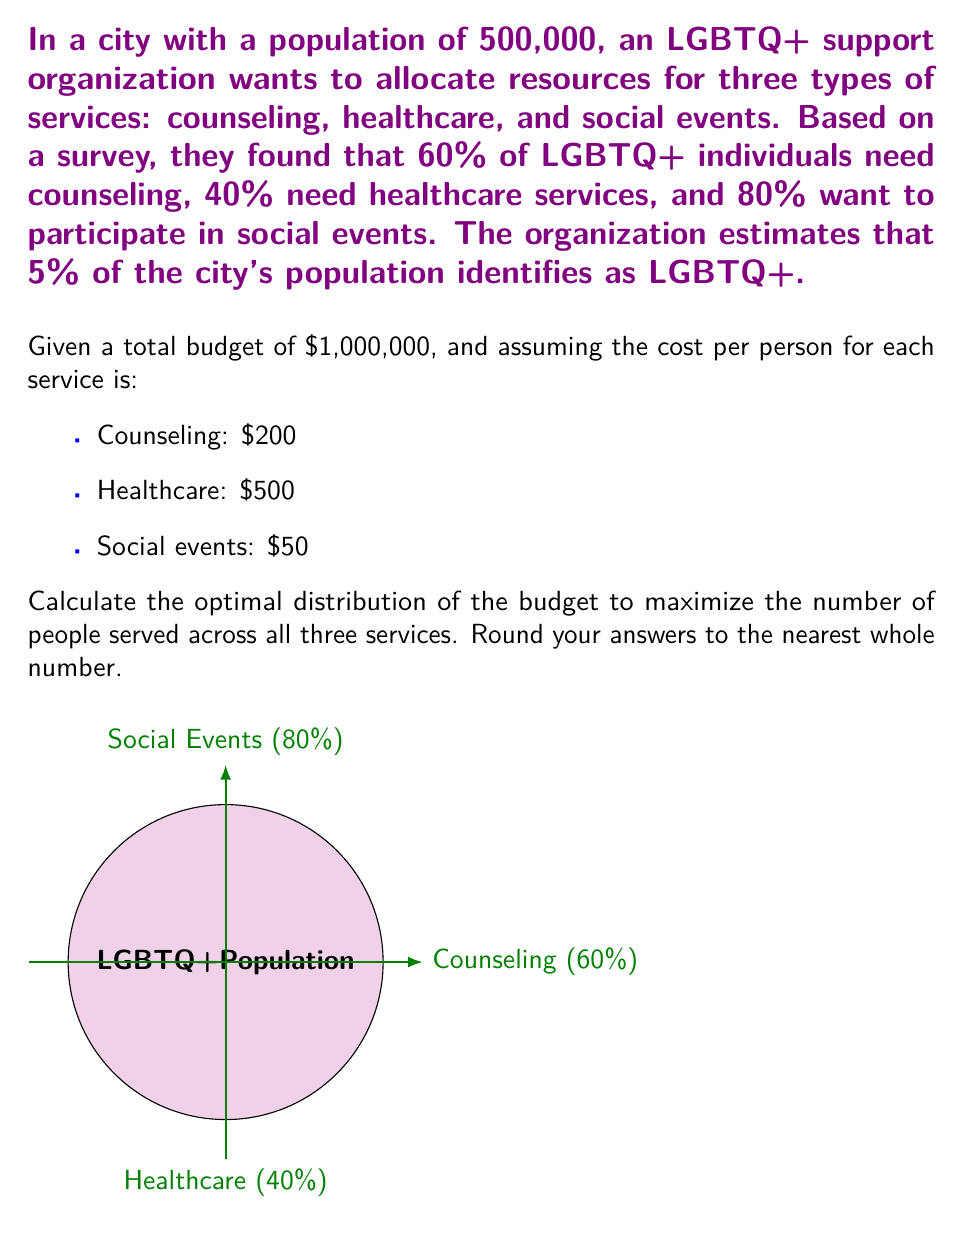Provide a solution to this math problem. Let's approach this step-by-step:

1) First, calculate the LGBTQ+ population in the city:
   $500,000 \times 5\% = 25,000$ LGBTQ+ individuals

2) Calculate the number of people needing each service:
   Counseling: $25,000 \times 60\% = 15,000$
   Healthcare: $25,000 \times 40\% = 10,000$
   Social events: $25,000 \times 80\% = 20,000$

3) Calculate the total cost if all needs were met:
   Counseling: $15,000 \times \$200 = \$3,000,000$
   Healthcare: $10,000 \times \$500 = \$5,000,000$
   Social events: $20,000 \times \$50 = \$1,000,000$
   Total: $\$9,000,000$

4) Since the budget is only $1,000,000, we need to distribute it optimally. To maximize the number of people served, we should prioritize the least expensive service first.

5) Allocate budget to social events:
   $20,000 \times \$50 = \$1,000,000$
   This exceeds the budget, so we can serve: $\frac{\$1,000,000}{\$50} = 20,000$ people

6) Remaining budget: $\$1,000,000 - \$1,000,000 = \$0$

7) There's no budget left for counseling or healthcare services.

8) Calculate the percentage of the budget for each service:
   Social events: $\frac{\$1,000,000}{\$1,000,000} \times 100\% = 100\%$
   Counseling: $0\%$
   Healthcare: $0\%$

Therefore, the optimal distribution to maximize the number of people served is to allocate 100% of the budget to social events.
Answer: Social events: 100%, Counseling: 0%, Healthcare: 0% 